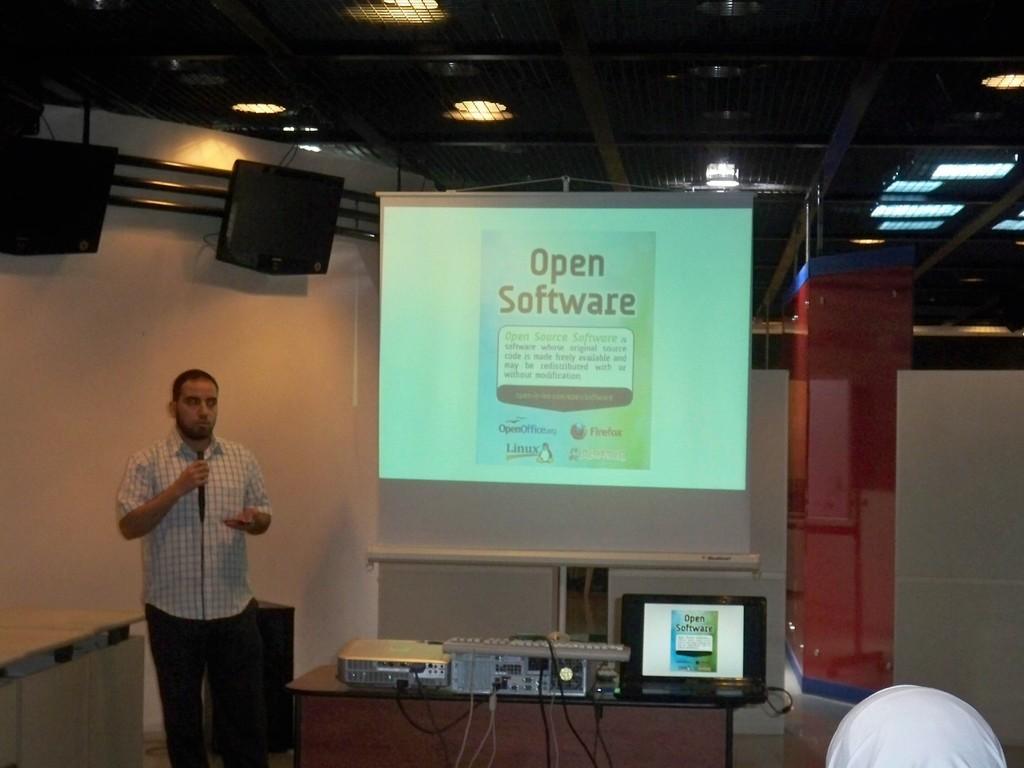Could you give a brief overview of what you see in this image? On the left side a man is standing and speaking in the microphone, he wore shirt, trouser. In the middle there is a projector screen. At the top there are lights to the roof, there is a laptop in this image. 